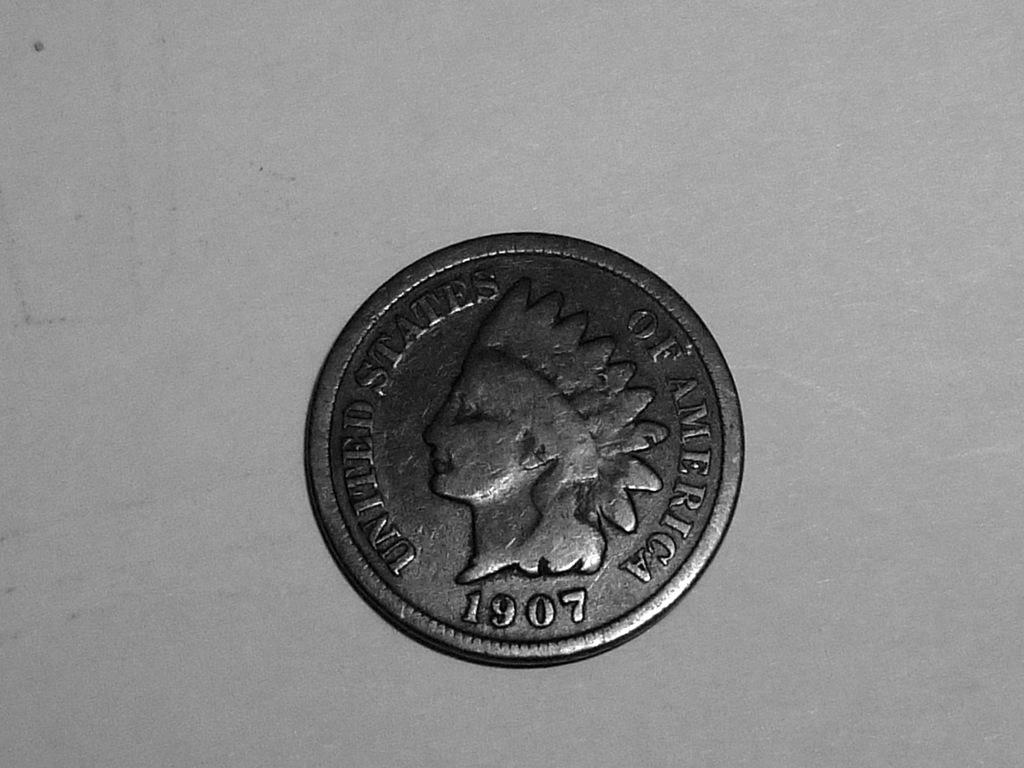<image>
Write a terse but informative summary of the picture. An old silver United States of America coin from 1907 